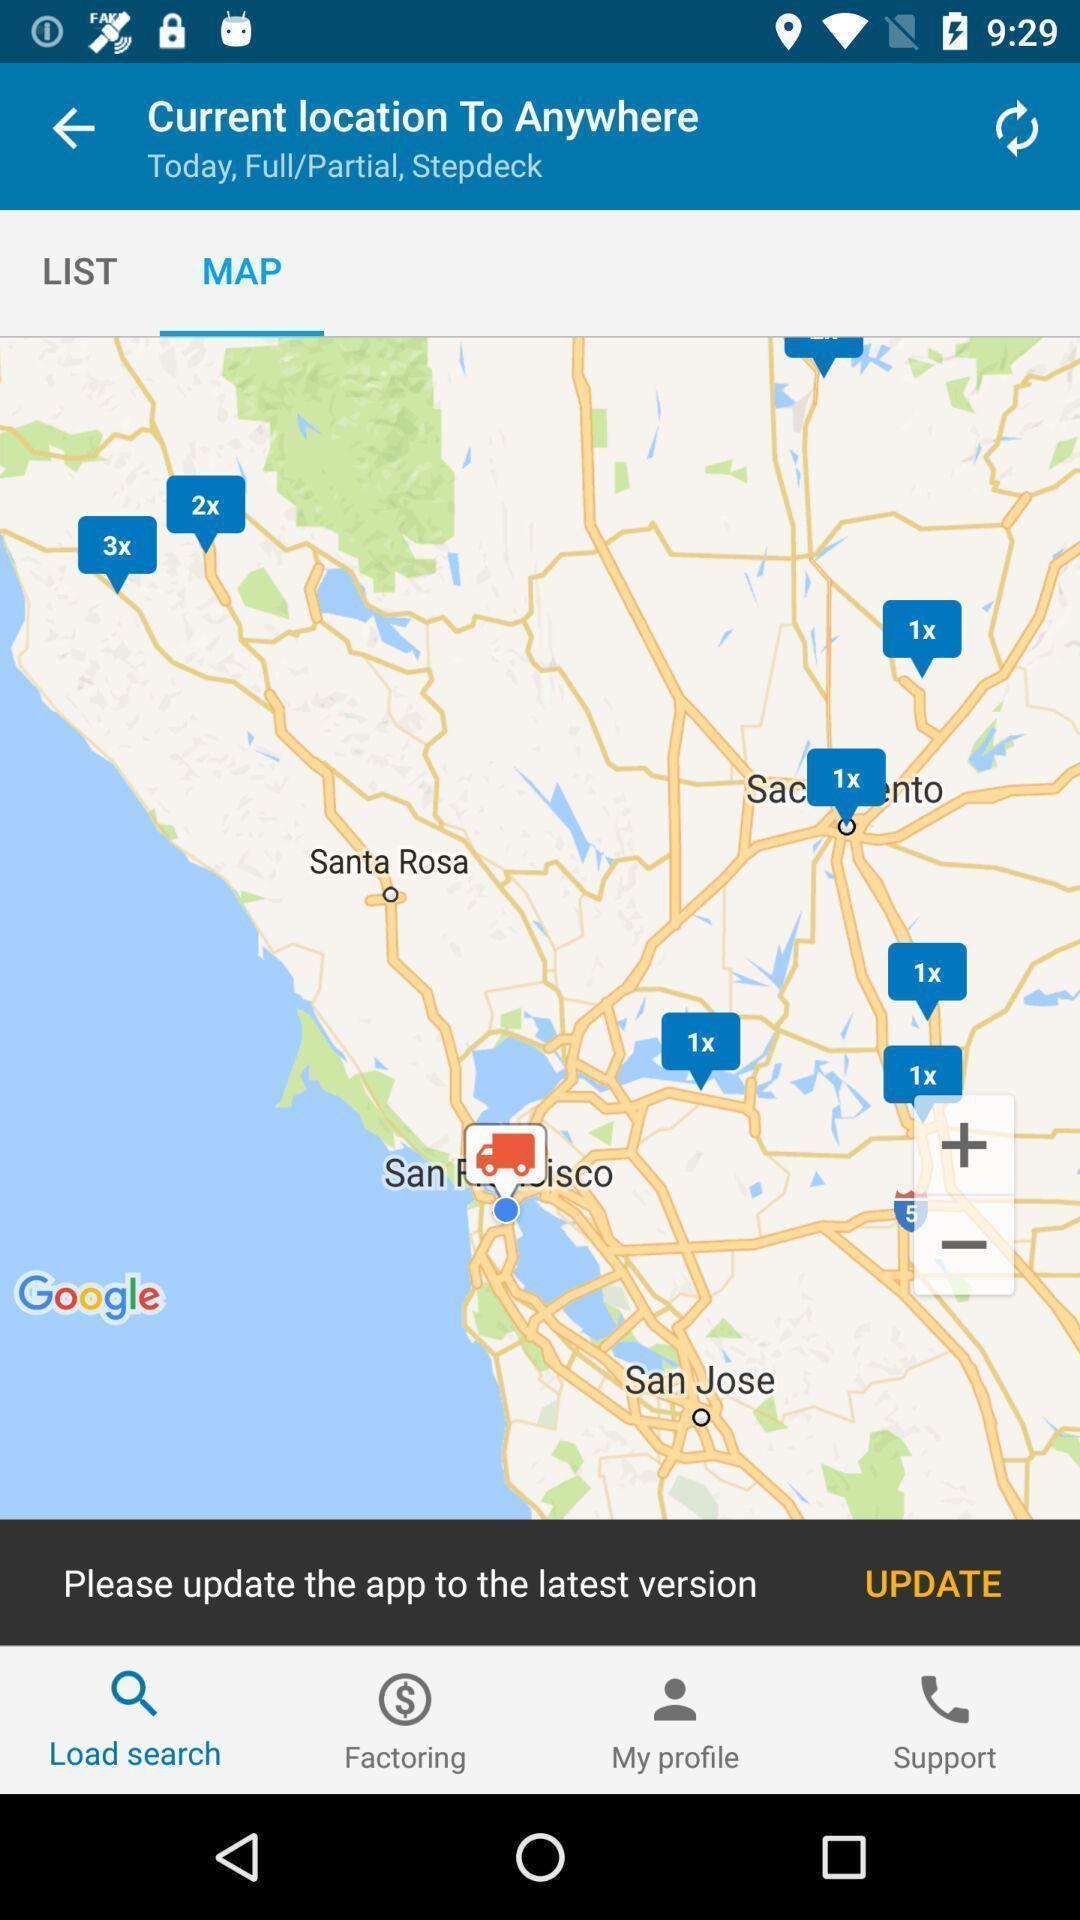Describe this image in words. Page showing the current location on a map. 